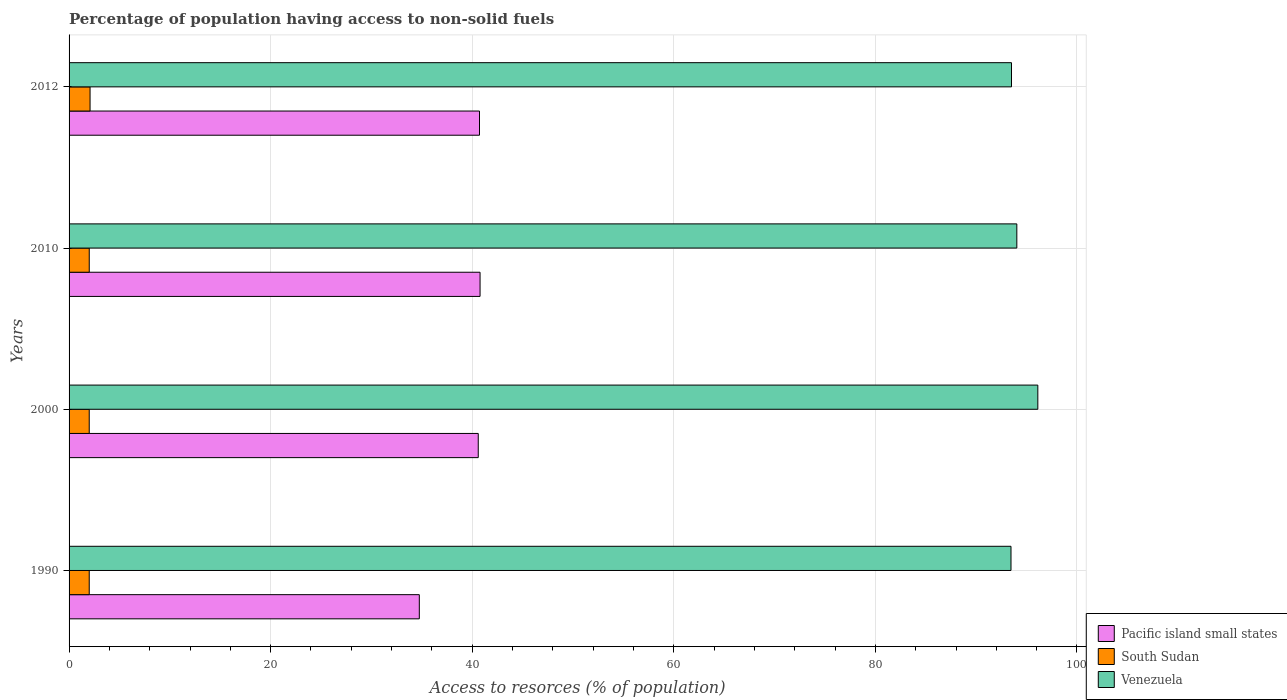How many different coloured bars are there?
Offer a very short reply. 3. How many groups of bars are there?
Keep it short and to the point. 4. Are the number of bars per tick equal to the number of legend labels?
Keep it short and to the point. Yes. Are the number of bars on each tick of the Y-axis equal?
Offer a terse response. Yes. In how many cases, is the number of bars for a given year not equal to the number of legend labels?
Offer a very short reply. 0. What is the percentage of population having access to non-solid fuels in Venezuela in 2010?
Your response must be concise. 94.03. Across all years, what is the maximum percentage of population having access to non-solid fuels in Venezuela?
Provide a succinct answer. 96.12. Across all years, what is the minimum percentage of population having access to non-solid fuels in Venezuela?
Your answer should be very brief. 93.45. What is the total percentage of population having access to non-solid fuels in Pacific island small states in the graph?
Keep it short and to the point. 156.84. What is the difference between the percentage of population having access to non-solid fuels in Pacific island small states in 2010 and that in 2012?
Offer a very short reply. 0.06. What is the difference between the percentage of population having access to non-solid fuels in Pacific island small states in 2010 and the percentage of population having access to non-solid fuels in Venezuela in 2000?
Offer a very short reply. -55.34. What is the average percentage of population having access to non-solid fuels in Pacific island small states per year?
Keep it short and to the point. 39.21. In the year 1990, what is the difference between the percentage of population having access to non-solid fuels in Pacific island small states and percentage of population having access to non-solid fuels in South Sudan?
Provide a short and direct response. 32.75. What is the ratio of the percentage of population having access to non-solid fuels in South Sudan in 1990 to that in 2010?
Give a very brief answer. 1. Is the percentage of population having access to non-solid fuels in Venezuela in 2000 less than that in 2010?
Provide a short and direct response. No. Is the difference between the percentage of population having access to non-solid fuels in Pacific island small states in 1990 and 2010 greater than the difference between the percentage of population having access to non-solid fuels in South Sudan in 1990 and 2010?
Your answer should be very brief. No. What is the difference between the highest and the second highest percentage of population having access to non-solid fuels in Venezuela?
Make the answer very short. 2.08. What is the difference between the highest and the lowest percentage of population having access to non-solid fuels in Venezuela?
Your answer should be compact. 2.66. In how many years, is the percentage of population having access to non-solid fuels in Pacific island small states greater than the average percentage of population having access to non-solid fuels in Pacific island small states taken over all years?
Give a very brief answer. 3. Is the sum of the percentage of population having access to non-solid fuels in South Sudan in 1990 and 2010 greater than the maximum percentage of population having access to non-solid fuels in Pacific island small states across all years?
Your answer should be very brief. No. What does the 2nd bar from the top in 1990 represents?
Offer a terse response. South Sudan. What does the 2nd bar from the bottom in 2010 represents?
Offer a very short reply. South Sudan. Is it the case that in every year, the sum of the percentage of population having access to non-solid fuels in Pacific island small states and percentage of population having access to non-solid fuels in Venezuela is greater than the percentage of population having access to non-solid fuels in South Sudan?
Your answer should be compact. Yes. How many bars are there?
Provide a short and direct response. 12. Are all the bars in the graph horizontal?
Offer a very short reply. Yes. What is the difference between two consecutive major ticks on the X-axis?
Give a very brief answer. 20. Are the values on the major ticks of X-axis written in scientific E-notation?
Your answer should be very brief. No. Does the graph contain any zero values?
Offer a very short reply. No. What is the title of the graph?
Provide a succinct answer. Percentage of population having access to non-solid fuels. Does "Sao Tome and Principe" appear as one of the legend labels in the graph?
Ensure brevity in your answer.  No. What is the label or title of the X-axis?
Your answer should be compact. Access to resorces (% of population). What is the label or title of the Y-axis?
Offer a very short reply. Years. What is the Access to resorces (% of population) in Pacific island small states in 1990?
Provide a succinct answer. 34.75. What is the Access to resorces (% of population) of South Sudan in 1990?
Keep it short and to the point. 2. What is the Access to resorces (% of population) of Venezuela in 1990?
Provide a succinct answer. 93.45. What is the Access to resorces (% of population) of Pacific island small states in 2000?
Your answer should be very brief. 40.6. What is the Access to resorces (% of population) of South Sudan in 2000?
Provide a succinct answer. 2. What is the Access to resorces (% of population) of Venezuela in 2000?
Provide a succinct answer. 96.12. What is the Access to resorces (% of population) of Pacific island small states in 2010?
Offer a very short reply. 40.78. What is the Access to resorces (% of population) of South Sudan in 2010?
Keep it short and to the point. 2. What is the Access to resorces (% of population) of Venezuela in 2010?
Make the answer very short. 94.03. What is the Access to resorces (% of population) of Pacific island small states in 2012?
Provide a succinct answer. 40.72. What is the Access to resorces (% of population) of South Sudan in 2012?
Provide a succinct answer. 2.08. What is the Access to resorces (% of population) in Venezuela in 2012?
Your answer should be very brief. 93.5. Across all years, what is the maximum Access to resorces (% of population) in Pacific island small states?
Keep it short and to the point. 40.78. Across all years, what is the maximum Access to resorces (% of population) in South Sudan?
Offer a terse response. 2.08. Across all years, what is the maximum Access to resorces (% of population) of Venezuela?
Provide a short and direct response. 96.12. Across all years, what is the minimum Access to resorces (% of population) of Pacific island small states?
Your answer should be very brief. 34.75. Across all years, what is the minimum Access to resorces (% of population) of South Sudan?
Provide a succinct answer. 2. Across all years, what is the minimum Access to resorces (% of population) of Venezuela?
Offer a terse response. 93.45. What is the total Access to resorces (% of population) of Pacific island small states in the graph?
Keep it short and to the point. 156.84. What is the total Access to resorces (% of population) in South Sudan in the graph?
Keep it short and to the point. 8.09. What is the total Access to resorces (% of population) of Venezuela in the graph?
Your answer should be compact. 377.1. What is the difference between the Access to resorces (% of population) in Pacific island small states in 1990 and that in 2000?
Your answer should be compact. -5.85. What is the difference between the Access to resorces (% of population) in South Sudan in 1990 and that in 2000?
Your response must be concise. 0. What is the difference between the Access to resorces (% of population) in Venezuela in 1990 and that in 2000?
Provide a short and direct response. -2.66. What is the difference between the Access to resorces (% of population) in Pacific island small states in 1990 and that in 2010?
Your answer should be compact. -6.03. What is the difference between the Access to resorces (% of population) in South Sudan in 1990 and that in 2010?
Make the answer very short. -0. What is the difference between the Access to resorces (% of population) in Venezuela in 1990 and that in 2010?
Offer a terse response. -0.58. What is the difference between the Access to resorces (% of population) of Pacific island small states in 1990 and that in 2012?
Your answer should be compact. -5.97. What is the difference between the Access to resorces (% of population) of South Sudan in 1990 and that in 2012?
Your response must be concise. -0.08. What is the difference between the Access to resorces (% of population) of Venezuela in 1990 and that in 2012?
Your answer should be compact. -0.05. What is the difference between the Access to resorces (% of population) of Pacific island small states in 2000 and that in 2010?
Make the answer very short. -0.18. What is the difference between the Access to resorces (% of population) of South Sudan in 2000 and that in 2010?
Provide a succinct answer. -0. What is the difference between the Access to resorces (% of population) of Venezuela in 2000 and that in 2010?
Make the answer very short. 2.08. What is the difference between the Access to resorces (% of population) in Pacific island small states in 2000 and that in 2012?
Give a very brief answer. -0.12. What is the difference between the Access to resorces (% of population) of South Sudan in 2000 and that in 2012?
Ensure brevity in your answer.  -0.08. What is the difference between the Access to resorces (% of population) of Venezuela in 2000 and that in 2012?
Your answer should be compact. 2.61. What is the difference between the Access to resorces (% of population) in Pacific island small states in 2010 and that in 2012?
Your response must be concise. 0.06. What is the difference between the Access to resorces (% of population) of South Sudan in 2010 and that in 2012?
Give a very brief answer. -0.08. What is the difference between the Access to resorces (% of population) of Venezuela in 2010 and that in 2012?
Provide a short and direct response. 0.53. What is the difference between the Access to resorces (% of population) in Pacific island small states in 1990 and the Access to resorces (% of population) in South Sudan in 2000?
Offer a very short reply. 32.75. What is the difference between the Access to resorces (% of population) in Pacific island small states in 1990 and the Access to resorces (% of population) in Venezuela in 2000?
Ensure brevity in your answer.  -61.37. What is the difference between the Access to resorces (% of population) in South Sudan in 1990 and the Access to resorces (% of population) in Venezuela in 2000?
Make the answer very short. -94.12. What is the difference between the Access to resorces (% of population) in Pacific island small states in 1990 and the Access to resorces (% of population) in South Sudan in 2010?
Keep it short and to the point. 32.75. What is the difference between the Access to resorces (% of population) of Pacific island small states in 1990 and the Access to resorces (% of population) of Venezuela in 2010?
Keep it short and to the point. -59.28. What is the difference between the Access to resorces (% of population) in South Sudan in 1990 and the Access to resorces (% of population) in Venezuela in 2010?
Provide a short and direct response. -92.03. What is the difference between the Access to resorces (% of population) in Pacific island small states in 1990 and the Access to resorces (% of population) in South Sudan in 2012?
Make the answer very short. 32.67. What is the difference between the Access to resorces (% of population) of Pacific island small states in 1990 and the Access to resorces (% of population) of Venezuela in 2012?
Give a very brief answer. -58.75. What is the difference between the Access to resorces (% of population) in South Sudan in 1990 and the Access to resorces (% of population) in Venezuela in 2012?
Keep it short and to the point. -91.5. What is the difference between the Access to resorces (% of population) in Pacific island small states in 2000 and the Access to resorces (% of population) in South Sudan in 2010?
Keep it short and to the point. 38.59. What is the difference between the Access to resorces (% of population) of Pacific island small states in 2000 and the Access to resorces (% of population) of Venezuela in 2010?
Offer a very short reply. -53.44. What is the difference between the Access to resorces (% of population) of South Sudan in 2000 and the Access to resorces (% of population) of Venezuela in 2010?
Provide a succinct answer. -92.03. What is the difference between the Access to resorces (% of population) in Pacific island small states in 2000 and the Access to resorces (% of population) in South Sudan in 2012?
Provide a succinct answer. 38.51. What is the difference between the Access to resorces (% of population) of Pacific island small states in 2000 and the Access to resorces (% of population) of Venezuela in 2012?
Provide a short and direct response. -52.91. What is the difference between the Access to resorces (% of population) in South Sudan in 2000 and the Access to resorces (% of population) in Venezuela in 2012?
Provide a short and direct response. -91.5. What is the difference between the Access to resorces (% of population) in Pacific island small states in 2010 and the Access to resorces (% of population) in South Sudan in 2012?
Offer a very short reply. 38.69. What is the difference between the Access to resorces (% of population) of Pacific island small states in 2010 and the Access to resorces (% of population) of Venezuela in 2012?
Keep it short and to the point. -52.73. What is the difference between the Access to resorces (% of population) of South Sudan in 2010 and the Access to resorces (% of population) of Venezuela in 2012?
Make the answer very short. -91.5. What is the average Access to resorces (% of population) of Pacific island small states per year?
Offer a terse response. 39.21. What is the average Access to resorces (% of population) of South Sudan per year?
Keep it short and to the point. 2.02. What is the average Access to resorces (% of population) in Venezuela per year?
Keep it short and to the point. 94.28. In the year 1990, what is the difference between the Access to resorces (% of population) in Pacific island small states and Access to resorces (% of population) in South Sudan?
Your answer should be compact. 32.75. In the year 1990, what is the difference between the Access to resorces (% of population) of Pacific island small states and Access to resorces (% of population) of Venezuela?
Offer a terse response. -58.7. In the year 1990, what is the difference between the Access to resorces (% of population) of South Sudan and Access to resorces (% of population) of Venezuela?
Give a very brief answer. -91.45. In the year 2000, what is the difference between the Access to resorces (% of population) of Pacific island small states and Access to resorces (% of population) of South Sudan?
Provide a short and direct response. 38.6. In the year 2000, what is the difference between the Access to resorces (% of population) in Pacific island small states and Access to resorces (% of population) in Venezuela?
Your answer should be very brief. -55.52. In the year 2000, what is the difference between the Access to resorces (% of population) in South Sudan and Access to resorces (% of population) in Venezuela?
Your answer should be very brief. -94.12. In the year 2010, what is the difference between the Access to resorces (% of population) of Pacific island small states and Access to resorces (% of population) of South Sudan?
Give a very brief answer. 38.77. In the year 2010, what is the difference between the Access to resorces (% of population) in Pacific island small states and Access to resorces (% of population) in Venezuela?
Provide a succinct answer. -53.26. In the year 2010, what is the difference between the Access to resorces (% of population) of South Sudan and Access to resorces (% of population) of Venezuela?
Offer a very short reply. -92.03. In the year 2012, what is the difference between the Access to resorces (% of population) in Pacific island small states and Access to resorces (% of population) in South Sudan?
Keep it short and to the point. 38.64. In the year 2012, what is the difference between the Access to resorces (% of population) of Pacific island small states and Access to resorces (% of population) of Venezuela?
Offer a terse response. -52.78. In the year 2012, what is the difference between the Access to resorces (% of population) in South Sudan and Access to resorces (% of population) in Venezuela?
Ensure brevity in your answer.  -91.42. What is the ratio of the Access to resorces (% of population) in Pacific island small states in 1990 to that in 2000?
Give a very brief answer. 0.86. What is the ratio of the Access to resorces (% of population) of Venezuela in 1990 to that in 2000?
Provide a short and direct response. 0.97. What is the ratio of the Access to resorces (% of population) of Pacific island small states in 1990 to that in 2010?
Give a very brief answer. 0.85. What is the ratio of the Access to resorces (% of population) in Pacific island small states in 1990 to that in 2012?
Ensure brevity in your answer.  0.85. What is the ratio of the Access to resorces (% of population) of South Sudan in 1990 to that in 2012?
Provide a short and direct response. 0.96. What is the ratio of the Access to resorces (% of population) of Venezuela in 1990 to that in 2012?
Your answer should be very brief. 1. What is the ratio of the Access to resorces (% of population) in Venezuela in 2000 to that in 2010?
Your response must be concise. 1.02. What is the ratio of the Access to resorces (% of population) in South Sudan in 2000 to that in 2012?
Your answer should be compact. 0.96. What is the ratio of the Access to resorces (% of population) in Venezuela in 2000 to that in 2012?
Provide a succinct answer. 1.03. What is the ratio of the Access to resorces (% of population) in Pacific island small states in 2010 to that in 2012?
Your response must be concise. 1. What is the ratio of the Access to resorces (% of population) of South Sudan in 2010 to that in 2012?
Keep it short and to the point. 0.96. What is the difference between the highest and the second highest Access to resorces (% of population) of Pacific island small states?
Provide a short and direct response. 0.06. What is the difference between the highest and the second highest Access to resorces (% of population) in South Sudan?
Offer a very short reply. 0.08. What is the difference between the highest and the second highest Access to resorces (% of population) in Venezuela?
Ensure brevity in your answer.  2.08. What is the difference between the highest and the lowest Access to resorces (% of population) in Pacific island small states?
Offer a very short reply. 6.03. What is the difference between the highest and the lowest Access to resorces (% of population) in South Sudan?
Keep it short and to the point. 0.08. What is the difference between the highest and the lowest Access to resorces (% of population) in Venezuela?
Your response must be concise. 2.66. 